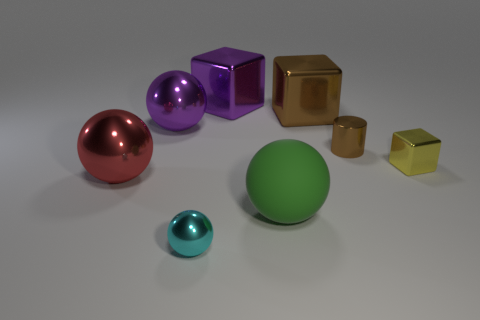Is the number of brown metallic cylinders that are in front of the big red metallic sphere less than the number of yellow objects?
Offer a very short reply. Yes. Does the small block have the same color as the metallic cylinder?
Ensure brevity in your answer.  No. What is the size of the yellow shiny object that is the same shape as the large brown thing?
Keep it short and to the point. Small. What number of other large blocks have the same material as the brown block?
Make the answer very short. 1. Do the sphere that is on the right side of the cyan object and the large brown object have the same material?
Your response must be concise. No. Is the number of big purple cubes behind the purple block the same as the number of things?
Your response must be concise. No. How big is the purple ball?
Your answer should be compact. Large. There is a large cube that is the same color as the tiny cylinder; what is its material?
Provide a succinct answer. Metal. How many big shiny spheres are the same color as the small cylinder?
Your answer should be compact. 0. Does the green rubber sphere have the same size as the metallic cylinder?
Give a very brief answer. No. 